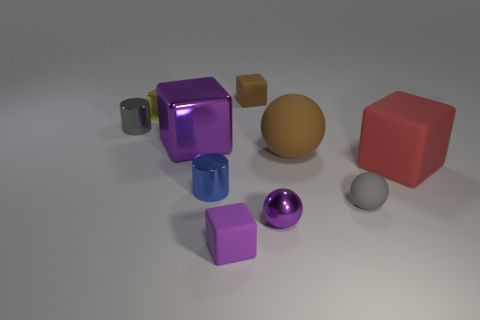There is a thing that is the same color as the big matte sphere; what is its shape?
Your response must be concise. Cube. What size is the matte object that is the same color as the big metallic block?
Your answer should be compact. Small. There is a small blue cylinder that is to the left of the brown rubber object that is in front of the big metallic block; is there a metallic cylinder that is behind it?
Your response must be concise. Yes. What number of other things are there of the same color as the large rubber sphere?
Ensure brevity in your answer.  1. How many blocks are on the right side of the brown matte ball and behind the gray cylinder?
Offer a terse response. 0. There is a tiny brown rubber object; what shape is it?
Offer a very short reply. Cube. How many other objects are there of the same material as the large red object?
Provide a short and direct response. 4. What is the color of the small rubber block in front of the brown thing in front of the tiny gray object on the left side of the yellow block?
Provide a succinct answer. Purple. There is a purple block that is the same size as the blue shiny thing; what is its material?
Your answer should be compact. Rubber. How many objects are rubber cubes that are behind the red rubber block or big brown cylinders?
Make the answer very short. 1. 